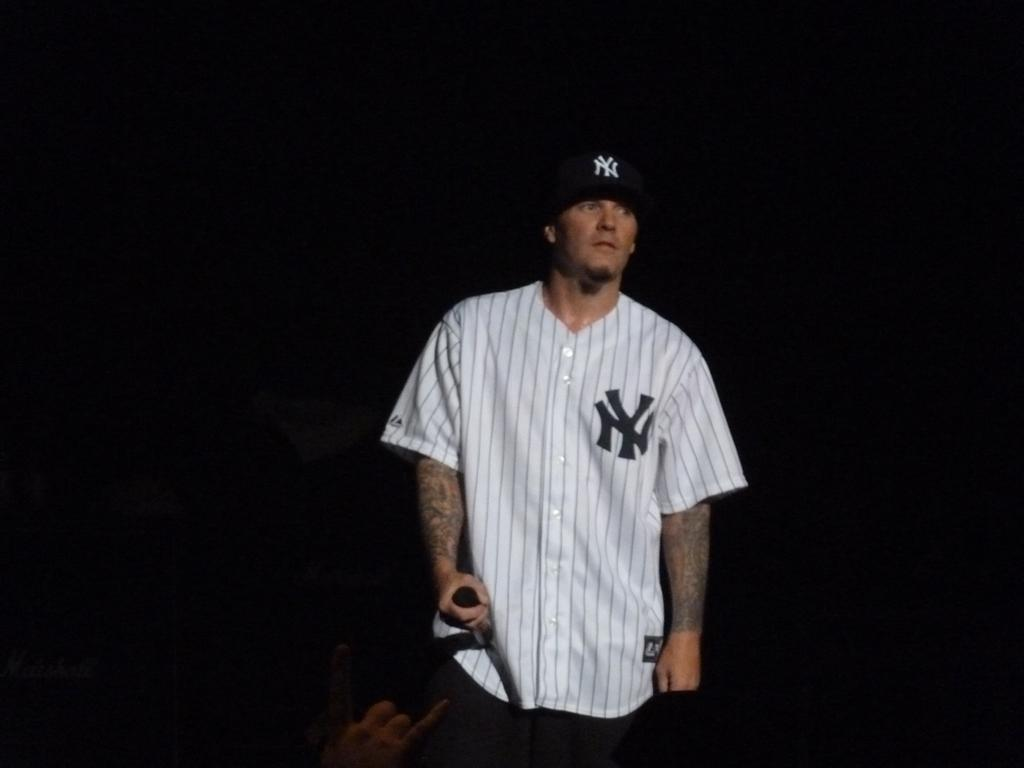<image>
Summarize the visual content of the image. The New York Yankees player is standing in a dark area. 